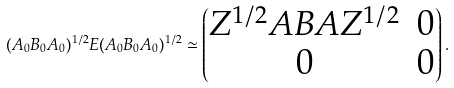<formula> <loc_0><loc_0><loc_500><loc_500>( A _ { 0 } B _ { 0 } A _ { 0 } ) ^ { 1 / 2 } E ( A _ { 0 } B _ { 0 } A _ { 0 } ) ^ { 1 / 2 } \simeq \begin{pmatrix} Z ^ { 1 / 2 } A B A Z ^ { 1 / 2 } & 0 \\ 0 & 0 \end{pmatrix} .</formula> 